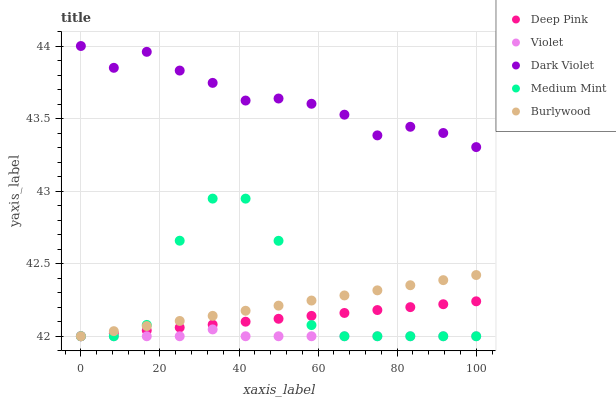Does Violet have the minimum area under the curve?
Answer yes or no. Yes. Does Dark Violet have the maximum area under the curve?
Answer yes or no. Yes. Does Burlywood have the minimum area under the curve?
Answer yes or no. No. Does Burlywood have the maximum area under the curve?
Answer yes or no. No. Is Burlywood the smoothest?
Answer yes or no. Yes. Is Medium Mint the roughest?
Answer yes or no. Yes. Is Deep Pink the smoothest?
Answer yes or no. No. Is Deep Pink the roughest?
Answer yes or no. No. Does Medium Mint have the lowest value?
Answer yes or no. Yes. Does Dark Violet have the lowest value?
Answer yes or no. No. Does Dark Violet have the highest value?
Answer yes or no. Yes. Does Burlywood have the highest value?
Answer yes or no. No. Is Violet less than Dark Violet?
Answer yes or no. Yes. Is Dark Violet greater than Medium Mint?
Answer yes or no. Yes. Does Deep Pink intersect Medium Mint?
Answer yes or no. Yes. Is Deep Pink less than Medium Mint?
Answer yes or no. No. Is Deep Pink greater than Medium Mint?
Answer yes or no. No. Does Violet intersect Dark Violet?
Answer yes or no. No. 